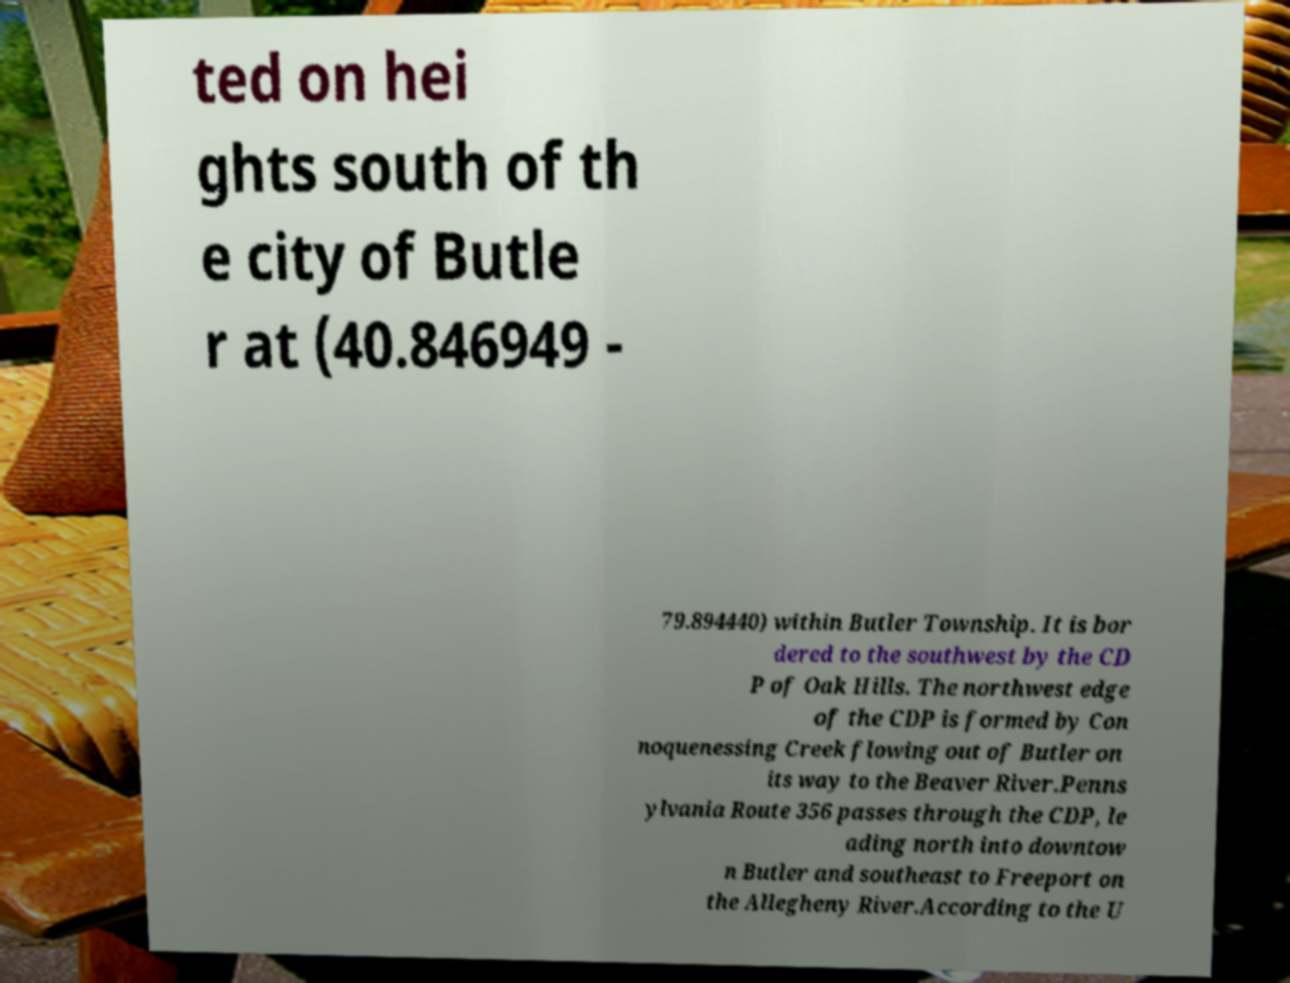Please identify and transcribe the text found in this image. ted on hei ghts south of th e city of Butle r at (40.846949 - 79.894440) within Butler Township. It is bor dered to the southwest by the CD P of Oak Hills. The northwest edge of the CDP is formed by Con noquenessing Creek flowing out of Butler on its way to the Beaver River.Penns ylvania Route 356 passes through the CDP, le ading north into downtow n Butler and southeast to Freeport on the Allegheny River.According to the U 